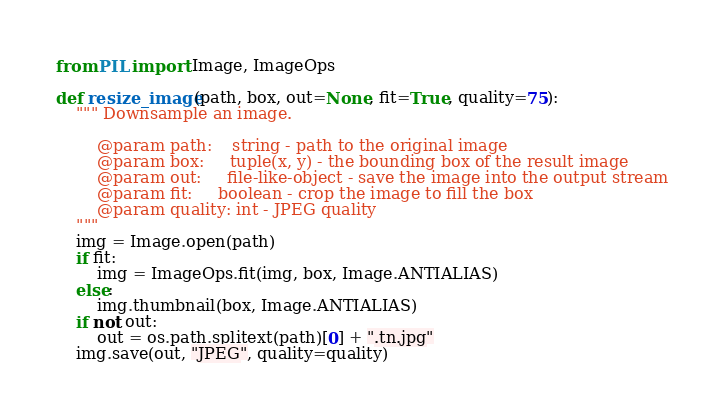<code> <loc_0><loc_0><loc_500><loc_500><_Python_>
from PIL import Image, ImageOps

def resize_image(path, box, out=None, fit=True, quality=75):
    """ Downsample an image.

        @param path:    string - path to the original image
        @param box:     tuple(x, y) - the bounding box of the result image
        @param out:     file-like-object - save the image into the output stream
        @param fit:     boolean - crop the image to fill the box
        @param quality: int - JPEG quality
    """
    img = Image.open(path)
    if fit:
        img = ImageOps.fit(img, box, Image.ANTIALIAS)
    else:
        img.thumbnail(box, Image.ANTIALIAS)
    if not out:
        out = os.path.splitext(path)[0] + ".tn.jpg"
    img.save(out, "JPEG", quality=quality)
</code> 